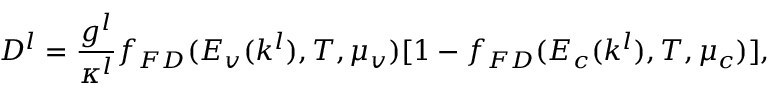Convert formula to latex. <formula><loc_0><loc_0><loc_500><loc_500>D ^ { l } = \frac { g ^ { l } } { \kappa ^ { l } } f _ { F D } ( E _ { v } ( k ^ { l } ) , T , \mu _ { v } ) [ 1 - f _ { F D } ( E _ { c } ( k ^ { l } ) , T , \mu _ { c } ) ] ,</formula> 